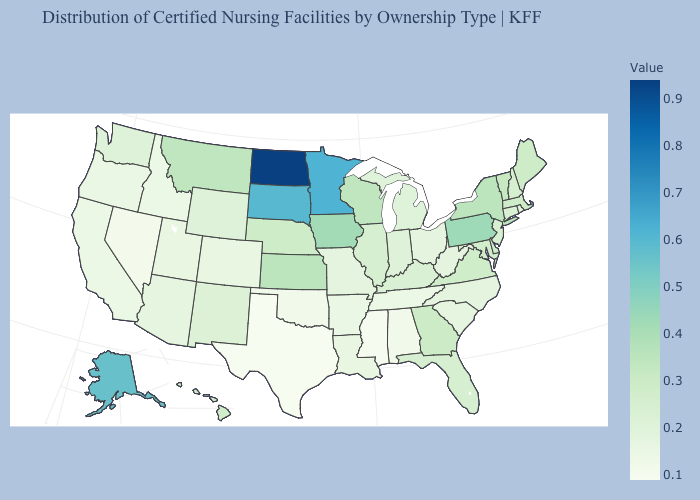Among the states that border Wisconsin , which have the lowest value?
Keep it brief. Michigan. Does the map have missing data?
Write a very short answer. No. Which states have the lowest value in the USA?
Be succinct. Texas. Does North Dakota have the lowest value in the MidWest?
Give a very brief answer. No. Which states have the lowest value in the MidWest?
Give a very brief answer. Missouri, Ohio. 